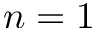Convert formula to latex. <formula><loc_0><loc_0><loc_500><loc_500>n = 1</formula> 